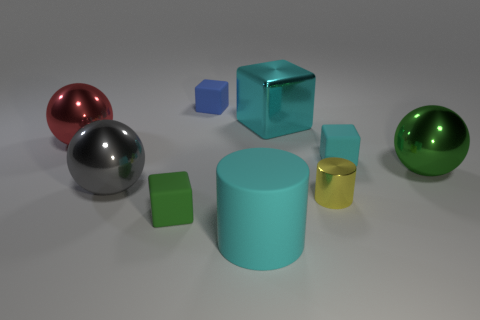Subtract all blue matte blocks. How many blocks are left? 3 Subtract all green balls. How many balls are left? 2 Subtract all cylinders. How many objects are left? 7 Subtract 3 blocks. How many blocks are left? 1 Subtract all gray balls. How many cyan cylinders are left? 1 Add 6 green balls. How many green balls are left? 7 Add 1 large gray things. How many large gray things exist? 2 Subtract 0 red cylinders. How many objects are left? 9 Subtract all gray balls. Subtract all cyan cylinders. How many balls are left? 2 Subtract all cyan rubber objects. Subtract all small yellow shiny things. How many objects are left? 6 